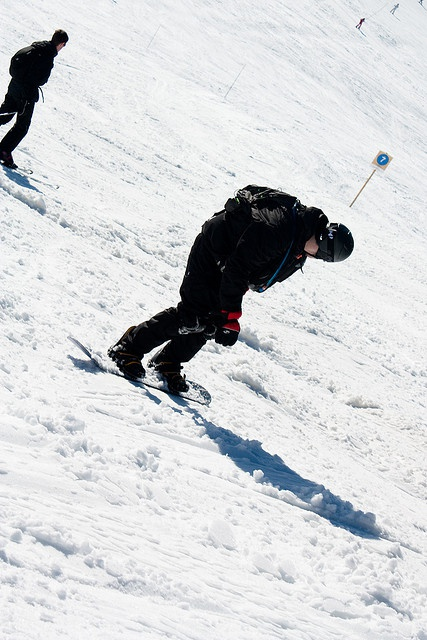Describe the objects in this image and their specific colors. I can see people in lightgray, black, gray, white, and darkgray tones, people in lightgray, black, gray, white, and navy tones, snowboard in lightgray, darkgray, black, and gray tones, backpack in lightgray, black, gray, darkgray, and white tones, and backpack in lightgray, black, gray, darkgray, and ivory tones in this image. 